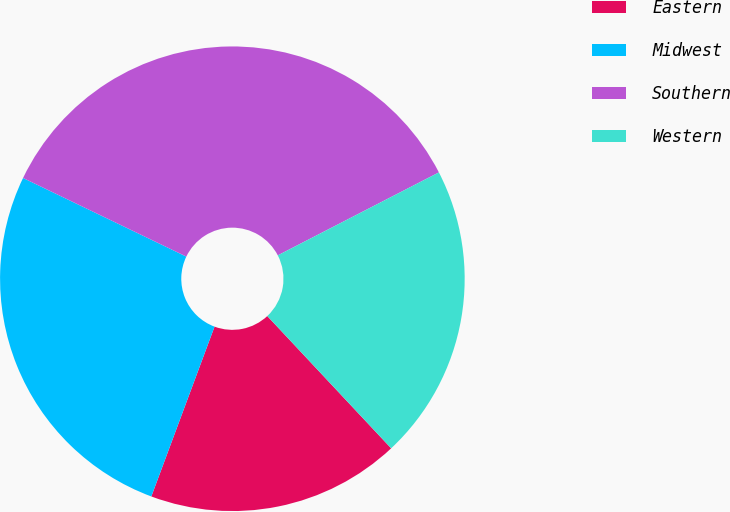Convert chart to OTSL. <chart><loc_0><loc_0><loc_500><loc_500><pie_chart><fcel>Eastern<fcel>Midwest<fcel>Southern<fcel>Western<nl><fcel>17.65%<fcel>26.47%<fcel>35.29%<fcel>20.59%<nl></chart> 